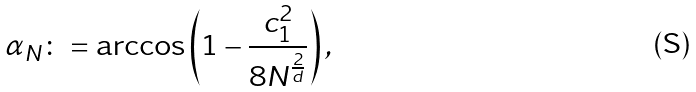Convert formula to latex. <formula><loc_0><loc_0><loc_500><loc_500>\alpha _ { N } \colon = \arccos \left ( 1 - \frac { c ^ { 2 } _ { 1 } } { 8 N ^ { \frac { 2 } { d } } } \right ) ,</formula> 